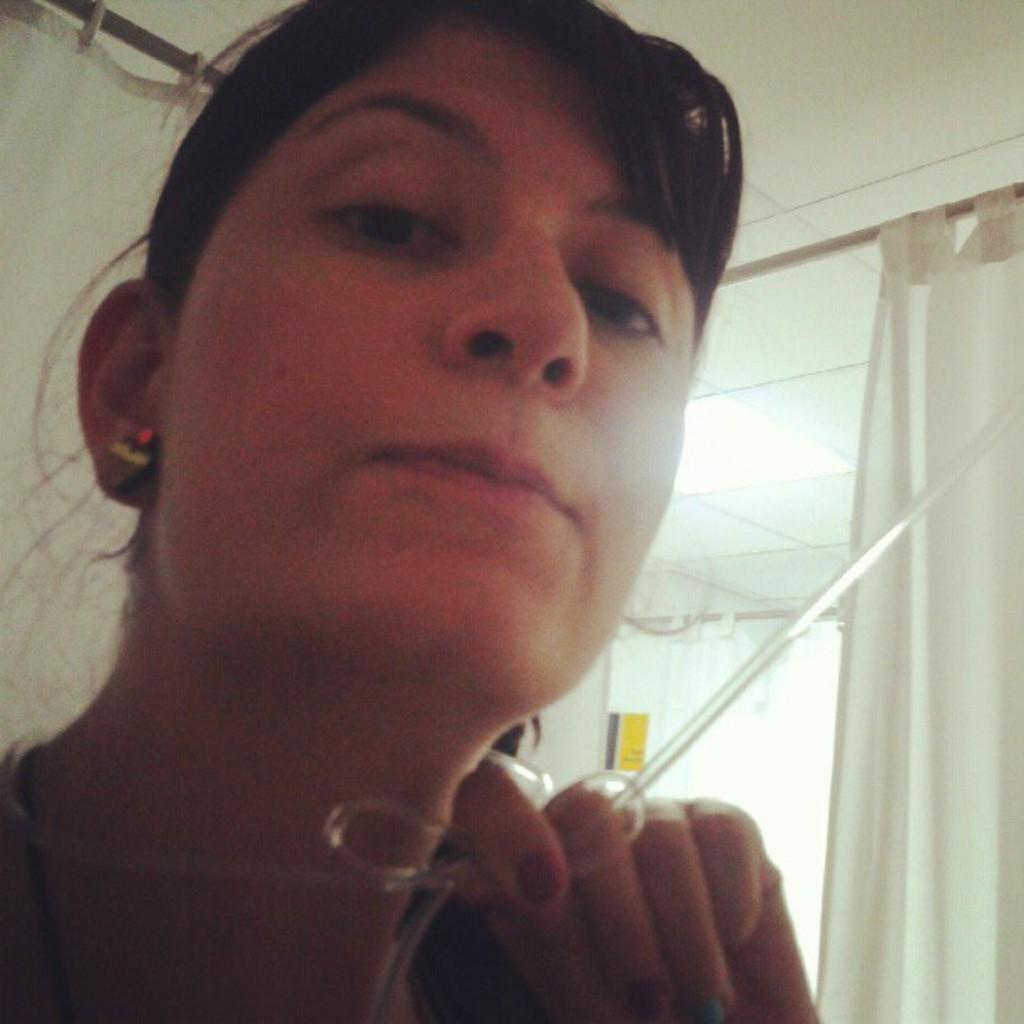Who is present in the image? There is a woman in the image. What is the woman holding in the image? The woman is holding a rubber pipe. What can be seen in the background of the image? There are curtains hanging on rods, a poster on a wall, the ceiling, and a light fixture visible in the background of the image. How many babies are present in the image? There are no babies present in the image. 